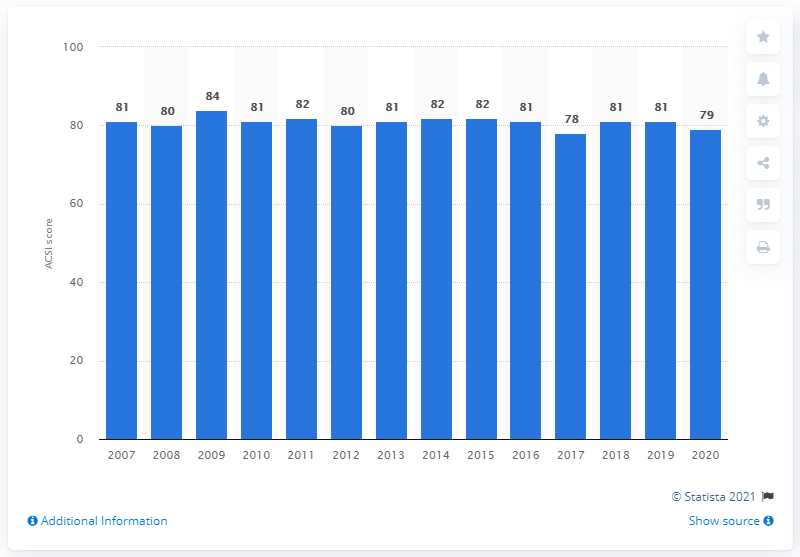Mention a couple of crucial points in this snapshot. The ACSI score for full-service restaurants in the United States in 2020 was 79, indicating a higher level of customer satisfaction compared to previous years. 